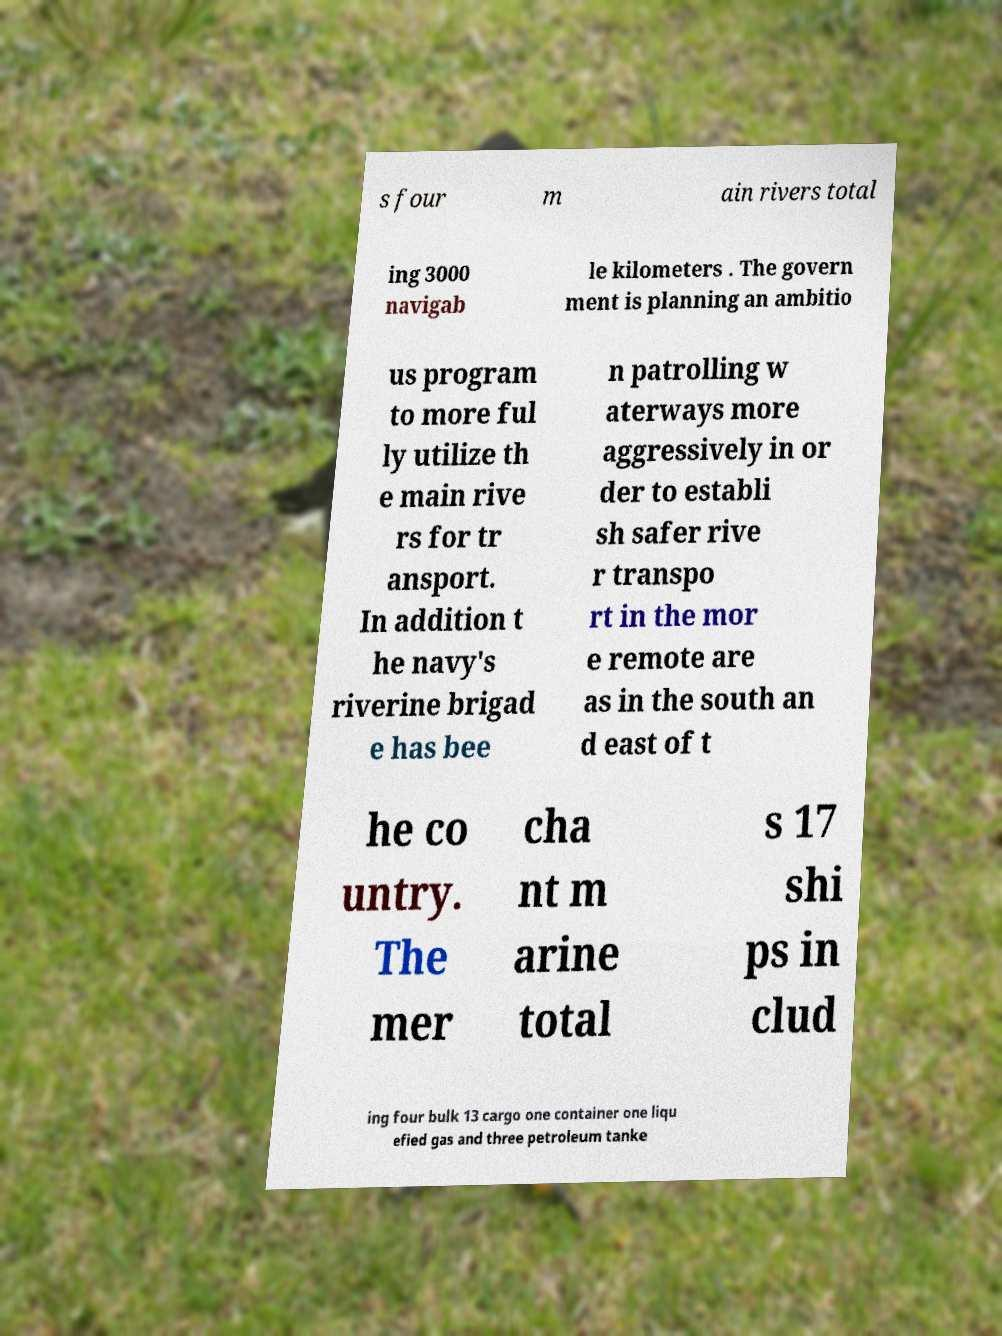Could you extract and type out the text from this image? s four m ain rivers total ing 3000 navigab le kilometers . The govern ment is planning an ambitio us program to more ful ly utilize th e main rive rs for tr ansport. In addition t he navy's riverine brigad e has bee n patrolling w aterways more aggressively in or der to establi sh safer rive r transpo rt in the mor e remote are as in the south an d east of t he co untry. The mer cha nt m arine total s 17 shi ps in clud ing four bulk 13 cargo one container one liqu efied gas and three petroleum tanke 